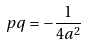<formula> <loc_0><loc_0><loc_500><loc_500>p q = - \frac { 1 } { 4 a ^ { 2 } }</formula> 